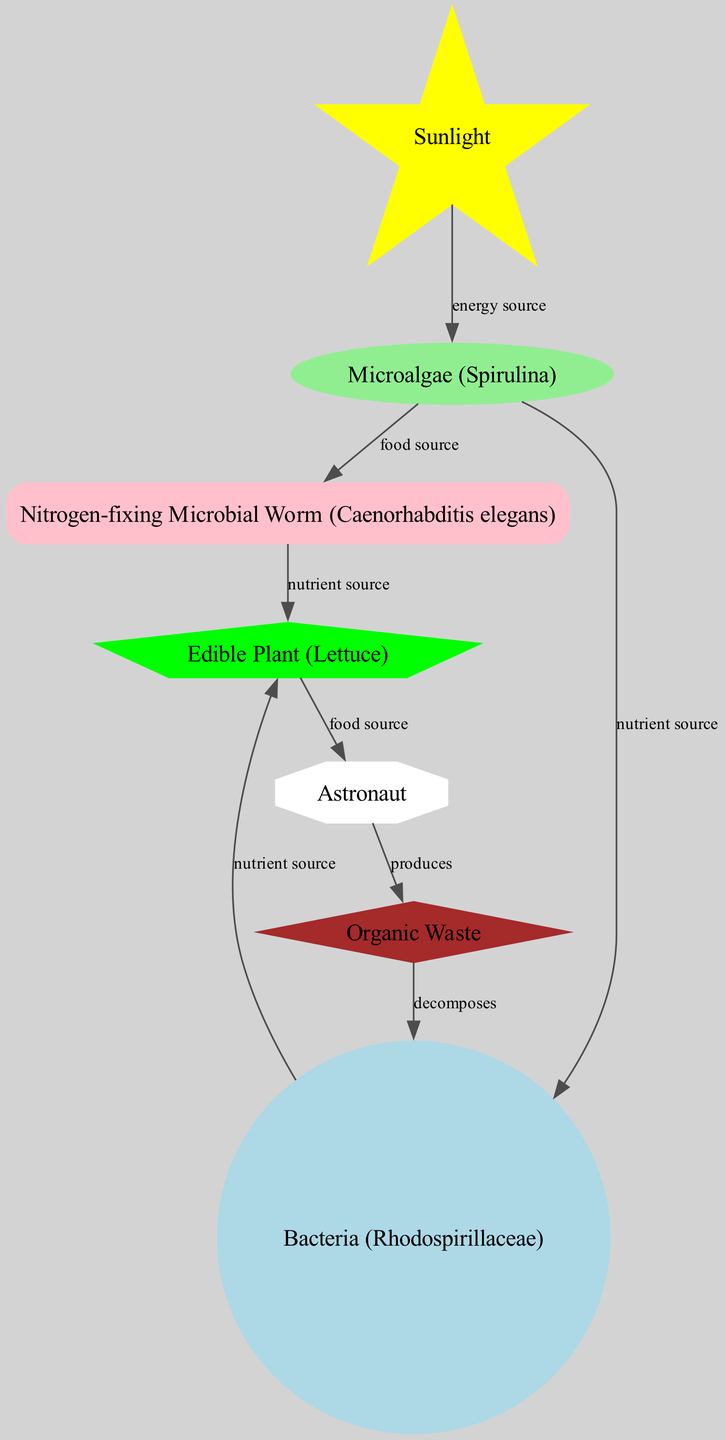What is the primary energy source in the diagram? The diagram indicates that "Sunlight" is the primary energy source, as indicated by its direct connection to "Microalgae" with the label "energy source."
Answer: Sunlight How many different types of organisms are depicted in the diagram? Counting the unique nodes that represent organisms, we see "Microalgae," "Nitrogen-fixing Microbial Worm," "Bacteria," "Plant," and "Astronaut," resulting in a total of five.
Answer: 5 Which organism is a direct food source for the astronaut? The diagram shows that "Plant" is connected to "Astronaut" with the label "food source," indicating that the plant provides food for the astronaut.
Answer: Edible Plant What role does organic waste play in the diagram? "Organic Waste" is connected to "Bacteria" with the label "decomposes," which shows that bacteria break down organic waste, recycling nutrients in the system.
Answer: Decomposes Which organism has a relationship labeled "nutrient source" with both the plant and the nitrogen-fixing microbial worm? "Bacteria" has connections labeled "nutrient source" to both "Plant" and "Nitrogen-fixing Microbial Worm," indicating its role in providing nutrients to both organisms.
Answer: Bacteria How many edges are there in the diagram? Counting all the connections (edges) that depict relationships between nodes, we identify eight edges in total.
Answer: 8 What is produced by the astronaut according to the diagram? The diagram states that the "Astronaut" produces "Organic Waste," as represented by the connection labeled "produces."
Answer: Organic Waste What is the nutrient source for the nitrogen-fixing microbial worm? "Microalgae" is indicated to be the food source for the nitrogen-fixing microbial worm in the diagram.
Answer: Microalgae Which component provides nutrients to bacteria in the chain? The diagram shows that "Microalgae" serves as a nutrient source for "Bacteria," indicated by the connecting edge labeled "nutrient source."
Answer: Microalgae Which diagram node has a shape resembling a star? The "Sunlight" node is depicted with a star shape, as specified in the custom node styles for the diagram.
Answer: Sunlight 